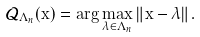<formula> <loc_0><loc_0><loc_500><loc_500>\mathcal { Q } _ { \Lambda _ { n } } ( \mathbf x ) = \arg \max _ { \lambda \in \Lambda _ { n } } \| \mathbf x - \lambda \| .</formula> 